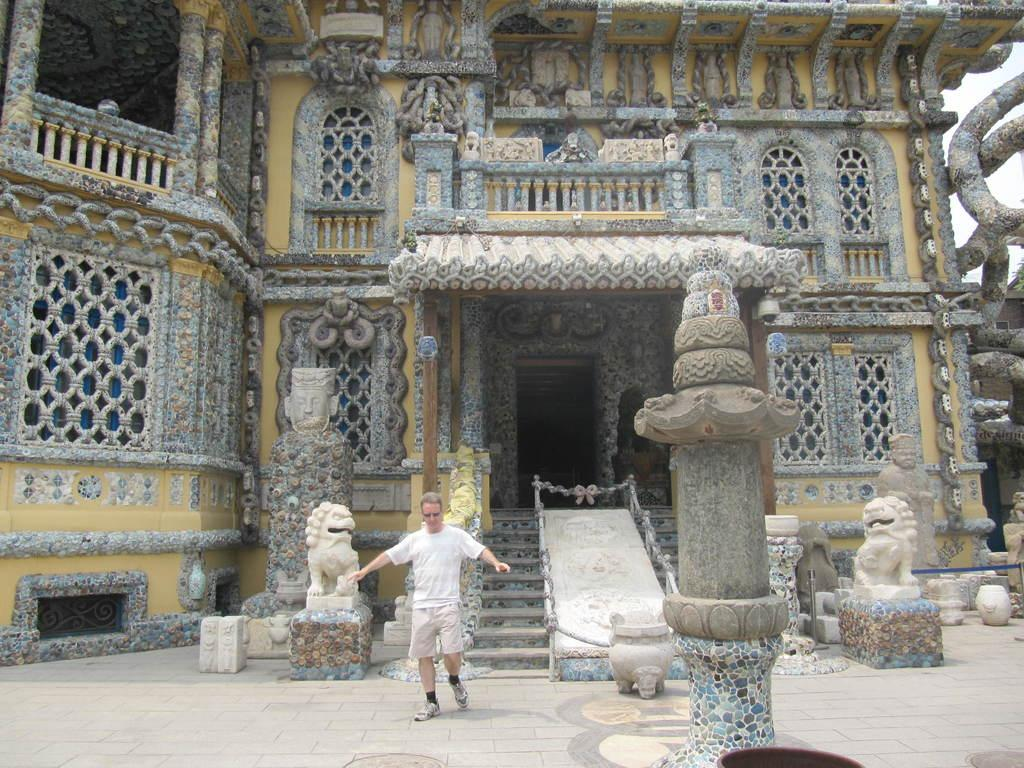Who or what is present in the image? There is a person in the image. Where is the person located in the image? The person is on a path. What can be seen in the background of the image? There are sculptures and a building in the background of the image. How much of the building is visible in the image? The building has a few inches visible. What type of lunch is the secretary eating in the image? There is no secretary or lunch present in the image. What room is the person in the image located in? The provided facts do not specify a room or any interior space; the person is on a path outdoors. 